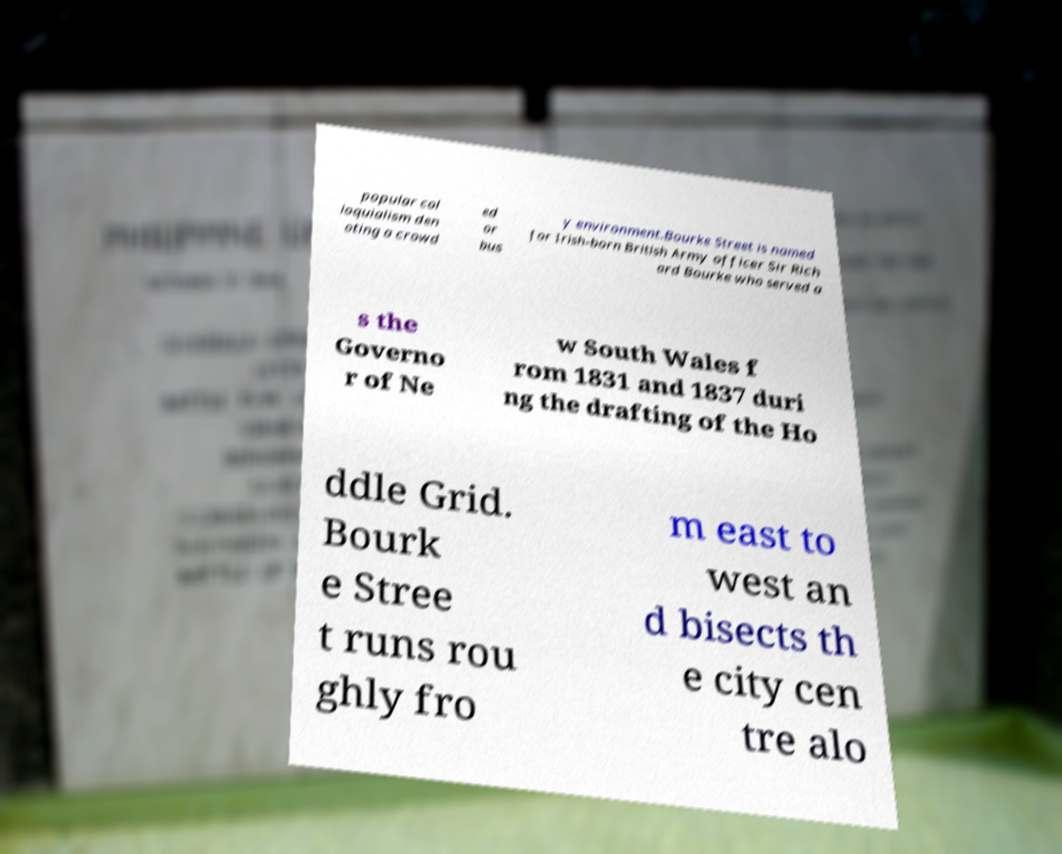For documentation purposes, I need the text within this image transcribed. Could you provide that? popular col loquialism den oting a crowd ed or bus y environment.Bourke Street is named for Irish-born British Army officer Sir Rich ard Bourke who served a s the Governo r of Ne w South Wales f rom 1831 and 1837 duri ng the drafting of the Ho ddle Grid. Bourk e Stree t runs rou ghly fro m east to west an d bisects th e city cen tre alo 